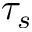<formula> <loc_0><loc_0><loc_500><loc_500>\tau _ { s }</formula> 